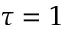<formula> <loc_0><loc_0><loc_500><loc_500>\tau = 1</formula> 